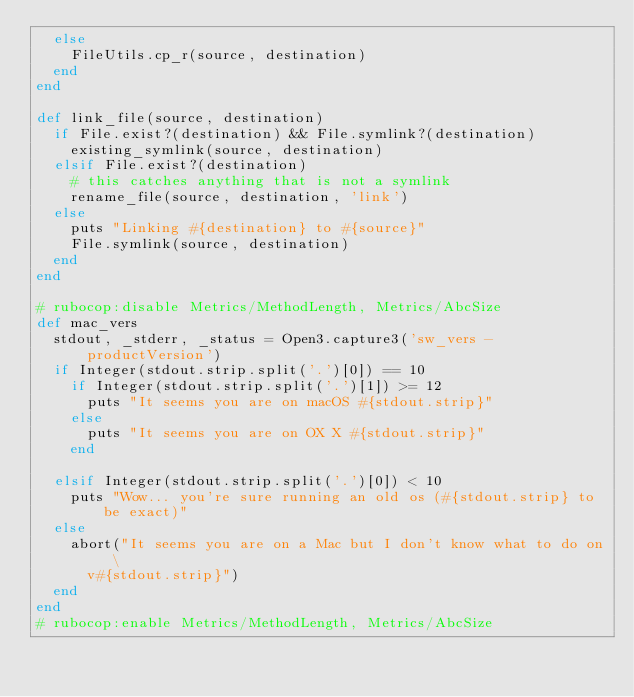Convert code to text. <code><loc_0><loc_0><loc_500><loc_500><_Ruby_>  else
    FileUtils.cp_r(source, destination)
  end
end

def link_file(source, destination)
  if File.exist?(destination) && File.symlink?(destination)
    existing_symlink(source, destination)
  elsif File.exist?(destination)
    # this catches anything that is not a symlink
    rename_file(source, destination, 'link')
  else
    puts "Linking #{destination} to #{source}"
    File.symlink(source, destination)
  end
end

# rubocop:disable Metrics/MethodLength, Metrics/AbcSize
def mac_vers
  stdout, _stderr, _status = Open3.capture3('sw_vers -productVersion')
  if Integer(stdout.strip.split('.')[0]) == 10
    if Integer(stdout.strip.split('.')[1]) >= 12
      puts "It seems you are on macOS #{stdout.strip}"
    else
      puts "It seems you are on OX X #{stdout.strip}"
    end

  elsif Integer(stdout.strip.split('.')[0]) < 10
    puts "Wow... you're sure running an old os (#{stdout.strip} to be exact)"
  else
    abort("It seems you are on a Mac but I don't know what to do on \
      v#{stdout.strip}")
  end
end
# rubocop:enable Metrics/MethodLength, Metrics/AbcSize
</code> 